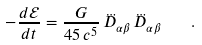Convert formula to latex. <formula><loc_0><loc_0><loc_500><loc_500>- \frac { d \mathcal { E } } { d t } = \frac { G } { 4 5 \, c ^ { 5 } } \, \dddot { D } _ { \alpha \beta } \, \dddot { D } _ { \alpha \beta } \quad .</formula> 